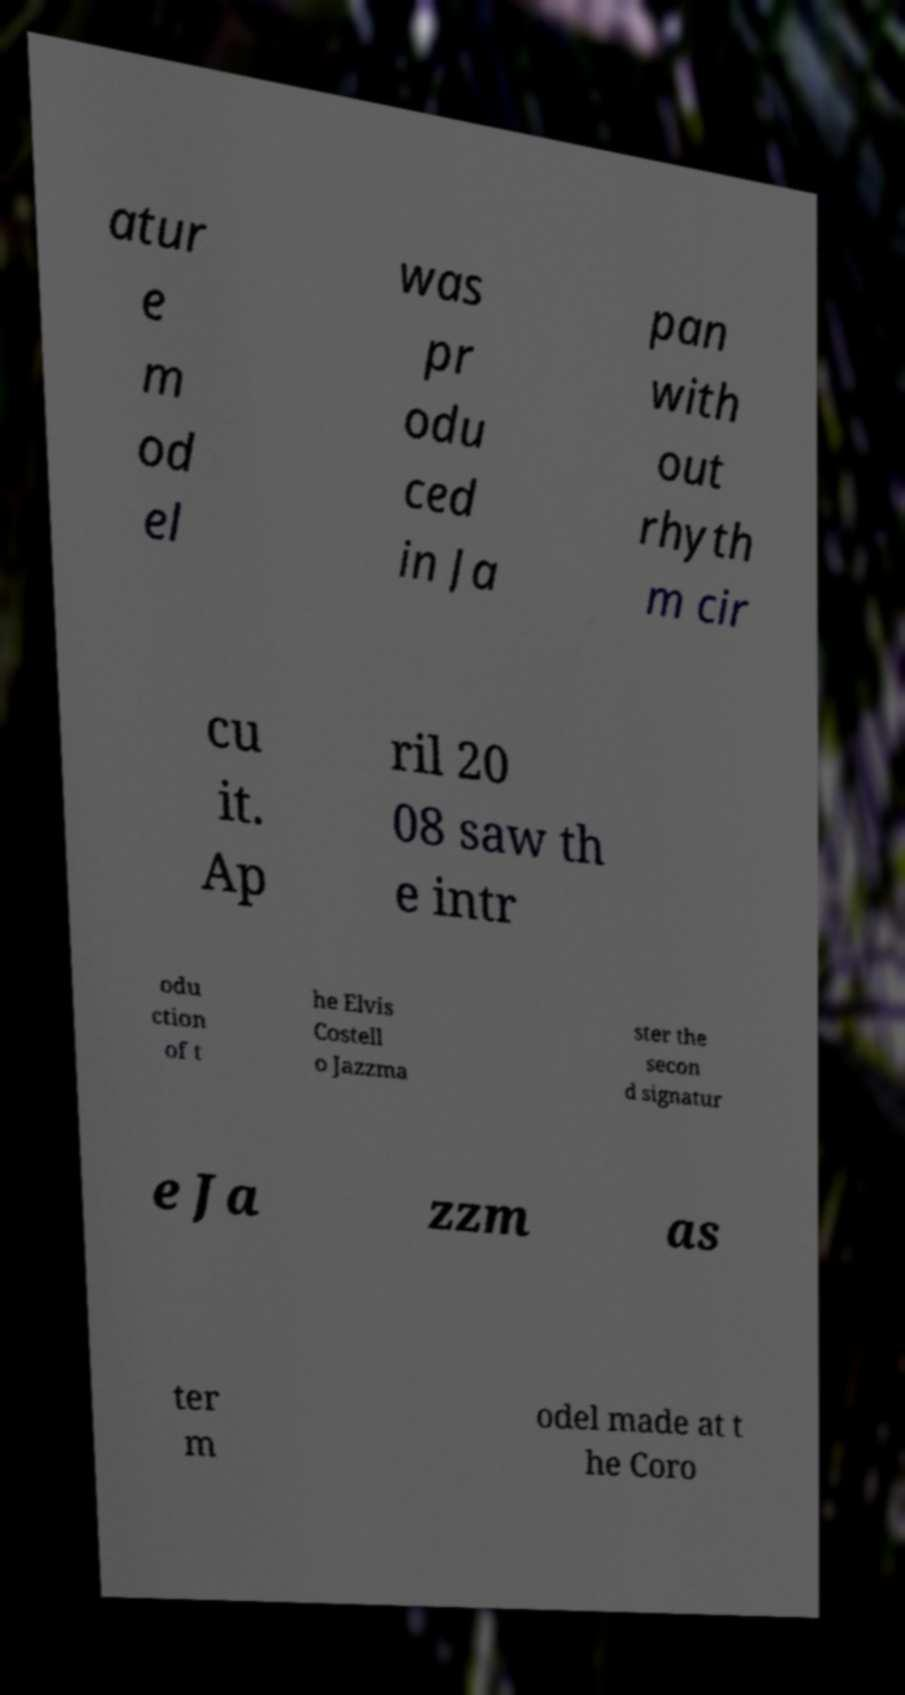Please identify and transcribe the text found in this image. atur e m od el was pr odu ced in Ja pan with out rhyth m cir cu it. Ap ril 20 08 saw th e intr odu ction of t he Elvis Costell o Jazzma ster the secon d signatur e Ja zzm as ter m odel made at t he Coro 